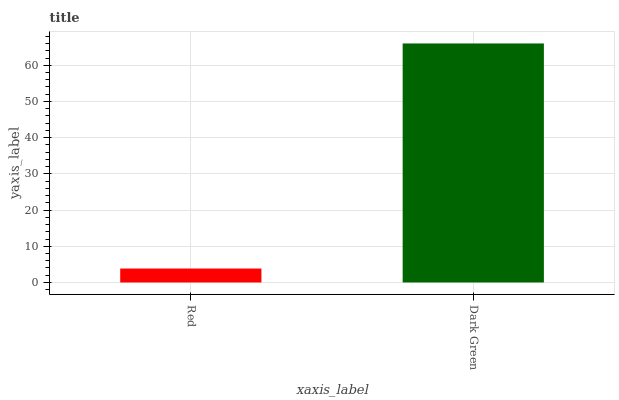Is Red the minimum?
Answer yes or no. Yes. Is Dark Green the maximum?
Answer yes or no. Yes. Is Dark Green the minimum?
Answer yes or no. No. Is Dark Green greater than Red?
Answer yes or no. Yes. Is Red less than Dark Green?
Answer yes or no. Yes. Is Red greater than Dark Green?
Answer yes or no. No. Is Dark Green less than Red?
Answer yes or no. No. Is Dark Green the high median?
Answer yes or no. Yes. Is Red the low median?
Answer yes or no. Yes. Is Red the high median?
Answer yes or no. No. Is Dark Green the low median?
Answer yes or no. No. 